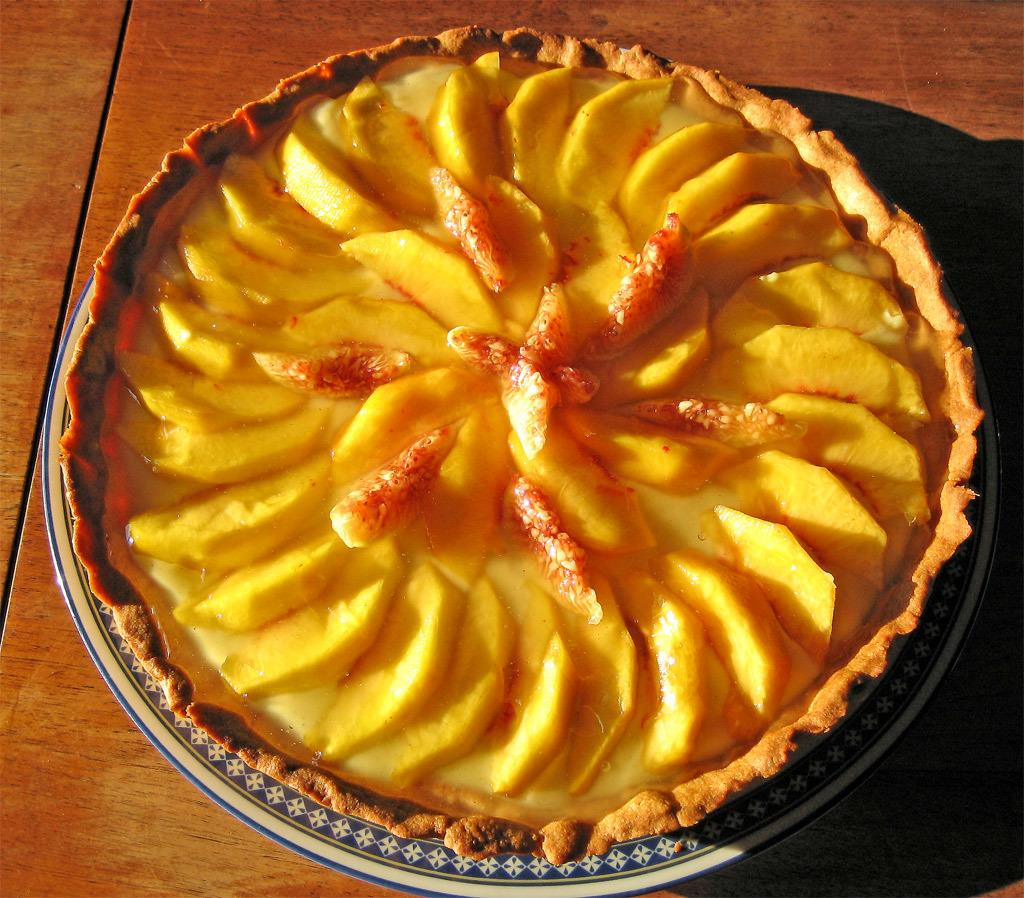What is on the plate that is visible in the image? There is a food item on a plate in the image. Where is the plate located in the image? The plate is placed on a table in the image. What arithmetic problem is being solved in the image? There is no arithmetic problem present in the image. What type of meeting is taking place in the image? There is no meeting depicted in the image. 